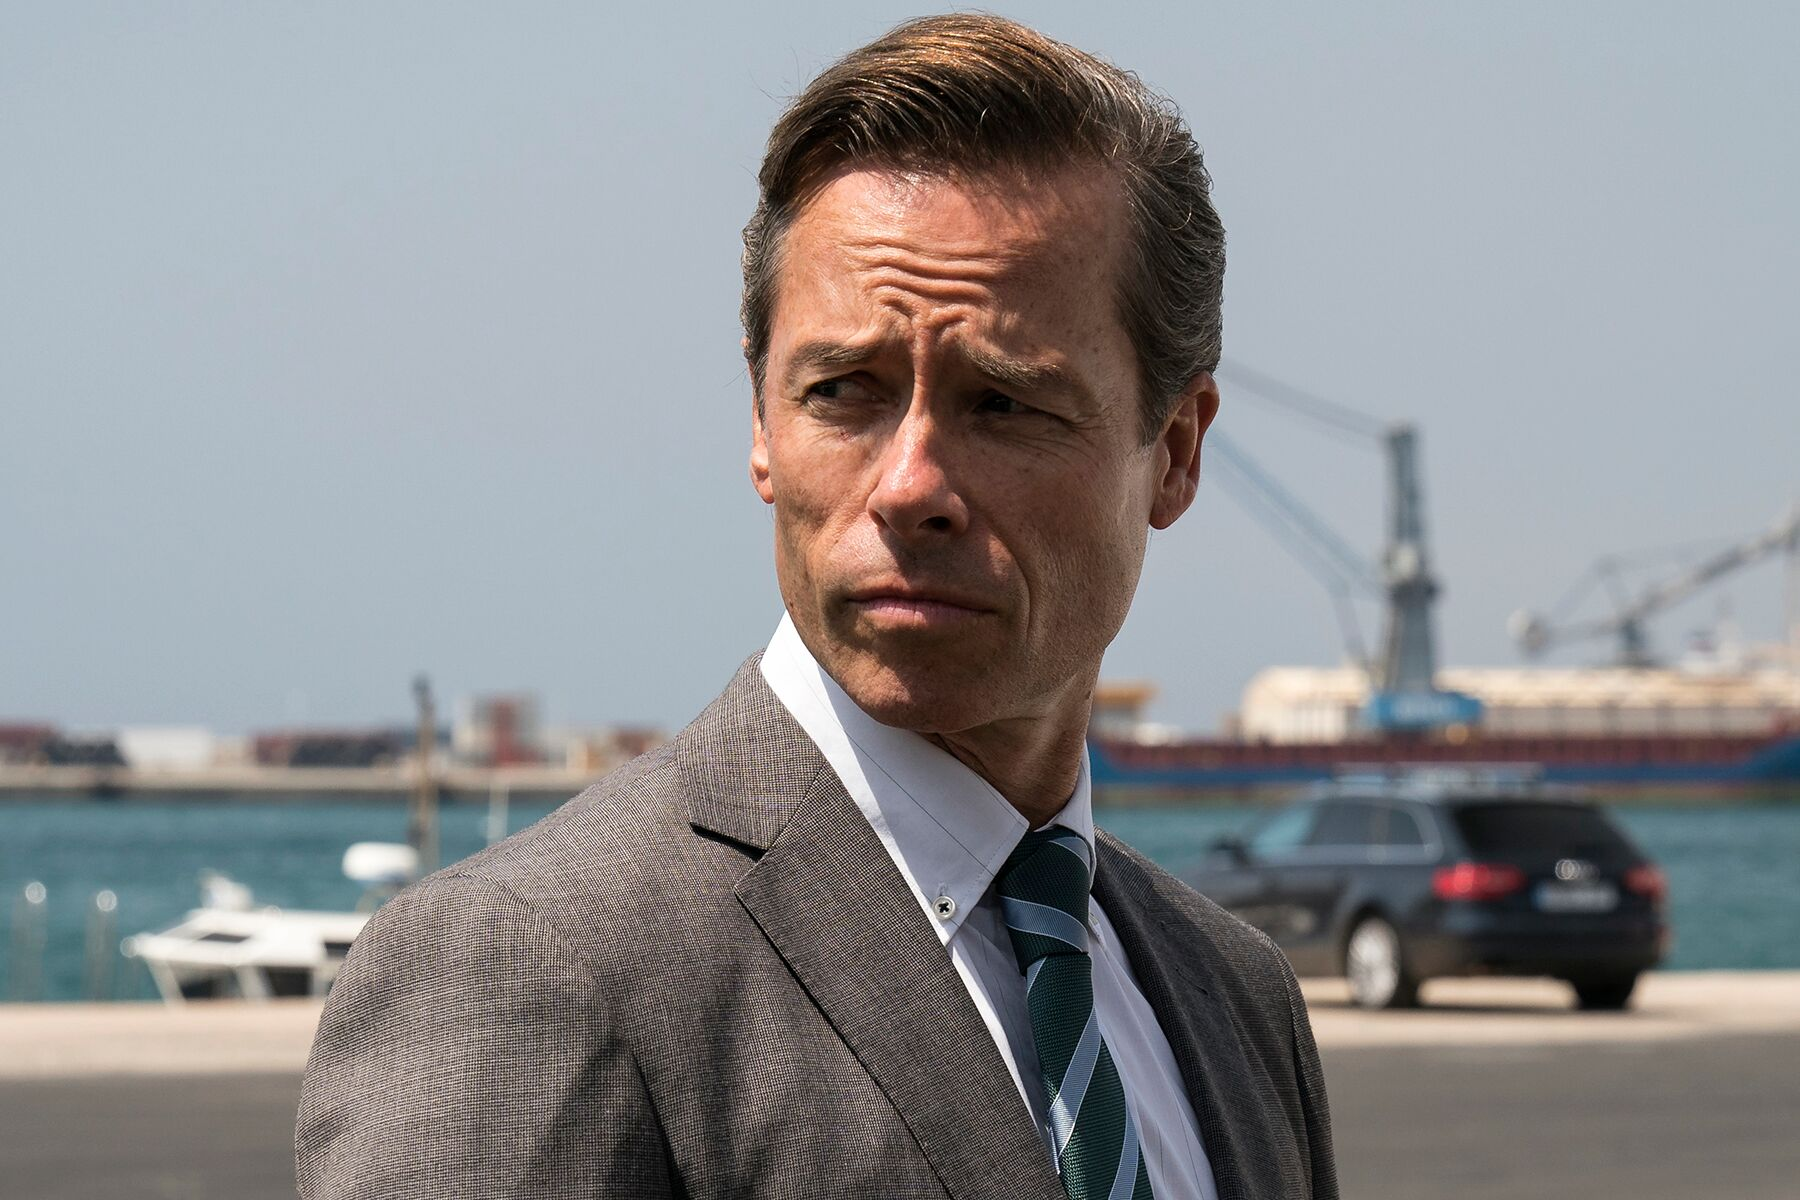Describe what the man could be thinking about. The man might be deeply pondering a strategic decision that could impact his business or personal life. His contemplative expression suggests that he is weighing various options, considering potential risks and benefits. He could be reflecting on a recent meeting, planning his next move, or anticipating future challenges within a competitive industry. The maritime backdrop implies that his thoughts might be connected to logistics, trade, or some form of large-scale operation that requires careful planning and execution. 